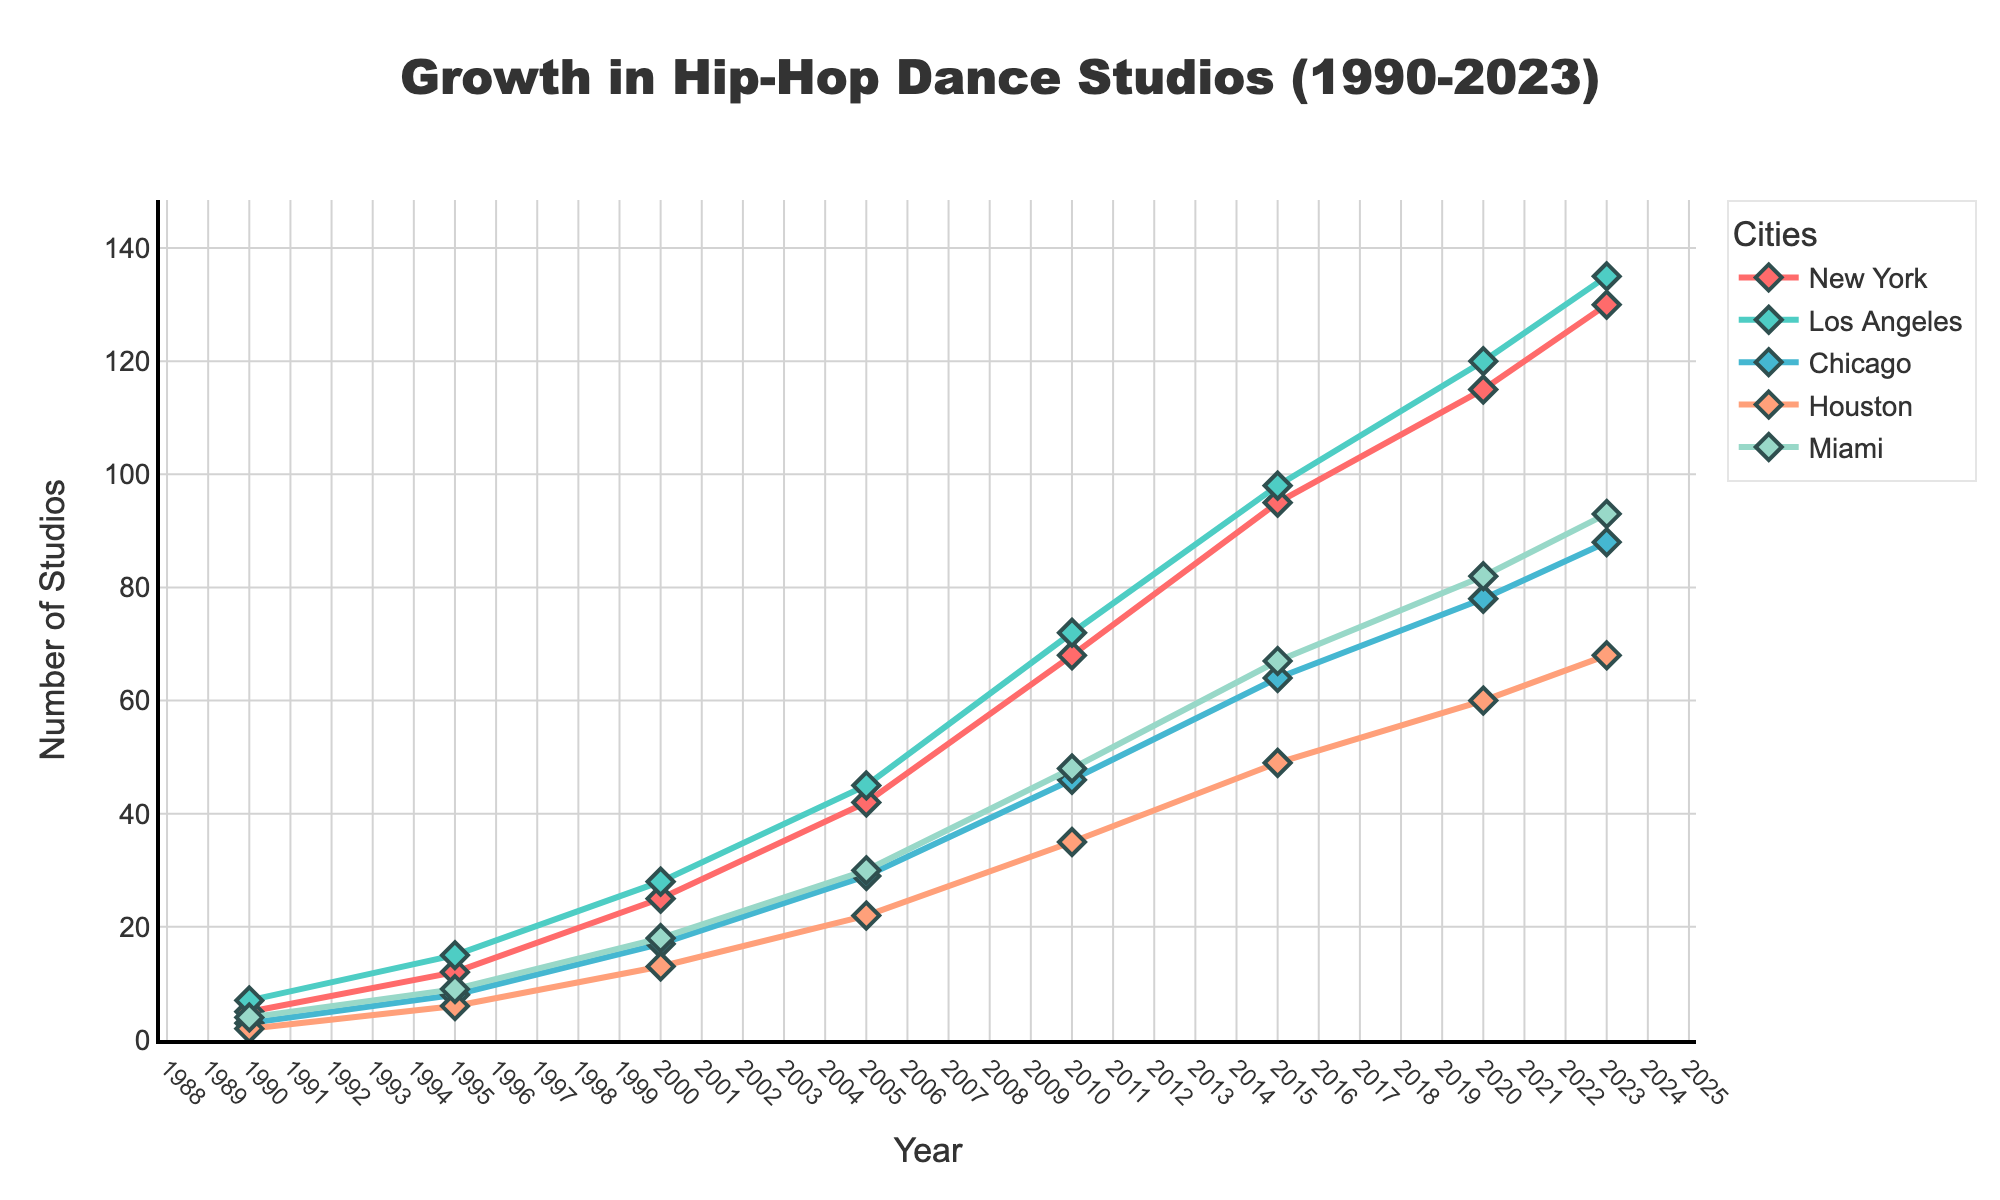what is the average number of hip-hop dance studios in New York in 2000 and 2010? To calculate the average, sum the number of studios in New York for 2000 and 2010 (25 + 68 = 93), and then divide by 2, giving 93/2 = 46.5
Answer: 46.5 Between Los Angeles and Miami, which city had more hip-hop dance studios in 2015? Compare the number of studios in 2015: Los Angeles had 98, and Miami had 67. Therefore, Los Angeles had more studios.
Answer: Los Angeles Which city saw the greatest increase in the number of studios from 1990 to 2023? To find the greatest increase, subtract the number of studios in 1990 from the number in 2023 for each city: New York (130-5=125), Los Angeles (135-7=128), Chicago (88-3=85), Houston (68-2=66), Miami (93-4=89). Los Angeles had the greatest increase of 128 studios.
Answer: Los Angeles How many studios in total were there in Houston and Miami in 2020? Add the number of studios in Houston and Miami in 2020: 60 + 82 = 142.
Answer: 142 Which year shows the steepest increase in the number of studios in Chicago? Viewing the plot, the steepest increase for Chicago appears between 1995 (8 studios) and 2000 (17 studios). The difference is 17-8=9.
Answer: 2000 By how many studios did New York grow between 1995 and 2020? The number of studios in New York in 2020 is 115, and in 1995 it was 12. The increase is 115-12=103.
Answer: 103 Compare the rate of increase in the number of studios between New York and Chicago from 2010 to 2023. Which one grew faster? New York had 68 in 2010 and 130 in 2023, an increase of 130-68=62. Chicago had 46 in 2010 and 88 in 2023, an increase of 88-46=42. Thus, New York grew faster.
Answer: New York At the end of the period (2023), which city had the least number of studios? In 2023, the number of studios in each city: New York (130), Los Angeles (135), Chicago (88), Houston (68), Miami (93). Houston had the least with 68.
Answer: Houston What is the total number of hip-hop dance studios across all cities in 2005? Sum the number of studios for each city in 2005: New York (42), Los Angeles (45), Chicago (29), Houston (22), Miami (30). Total is 42+45+29+22+30=168.
Answer: 168 How many years after 1990 did New York reach 50 studios? New York reached 50 studios between 2005 (42 studios) and 2010 (68 studios). Estimating linearly, it would be around 2007. So, it's approximately 2007-1990=17 years.
Answer: 17 years 